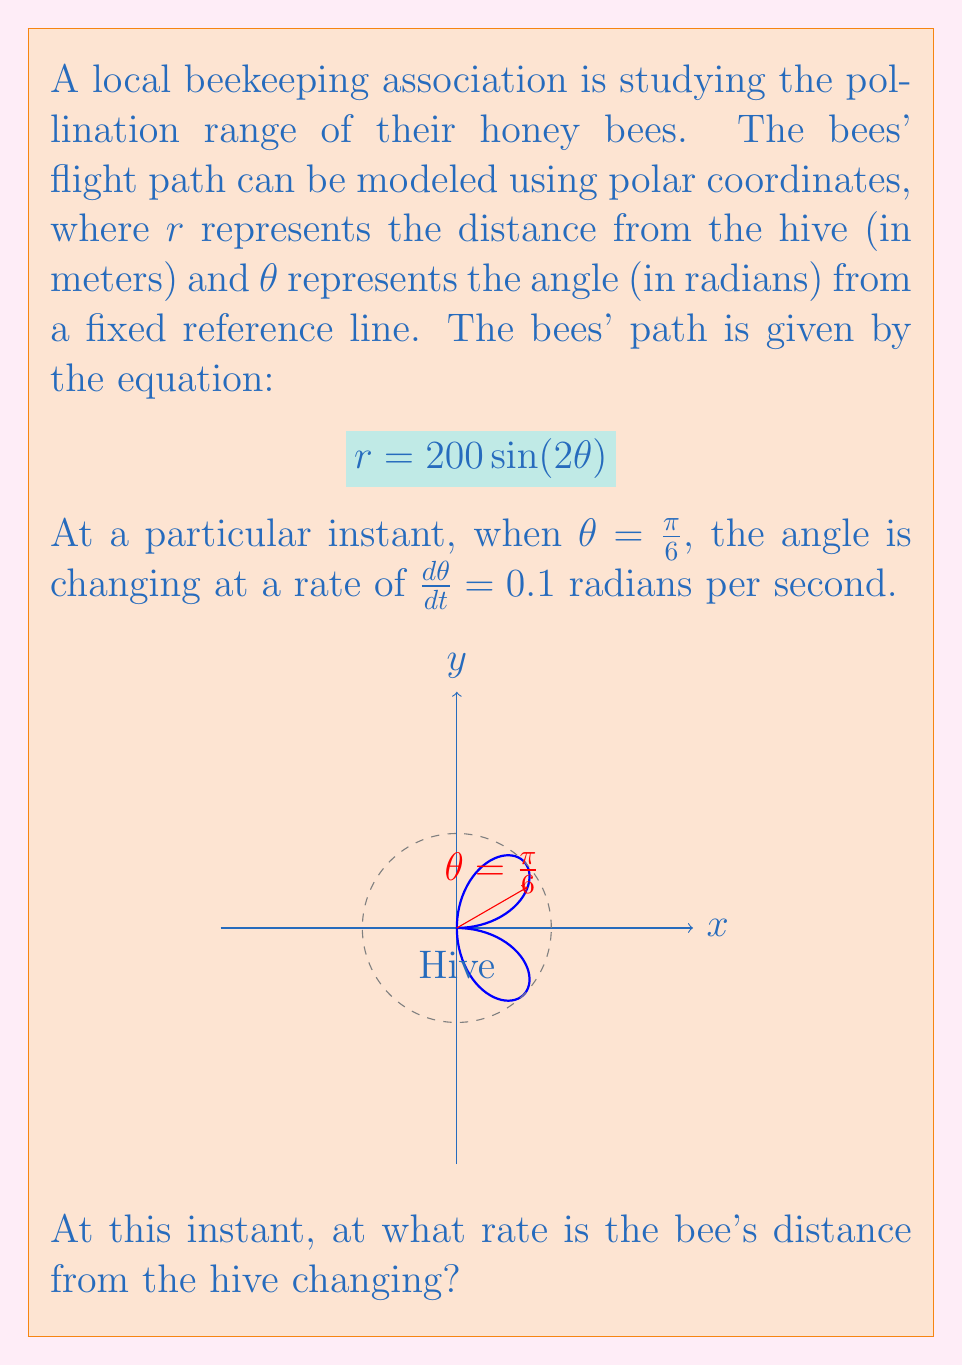What is the answer to this math problem? Let's approach this step-by-step using related rates:

1) We're given the polar equation $r = 200\sin(2\theta)$.

2) To find $\frac{dr}{dt}$, we need to use the chain rule:

   $$\frac{dr}{dt} = \frac{dr}{d\theta} \cdot \frac{d\theta}{dt}$$

3) We know $\frac{d\theta}{dt} = 0.1$ rad/s. Now we need to find $\frac{dr}{d\theta}$.

4) Differentiate $r$ with respect to $\theta$:

   $$\frac{dr}{d\theta} = 200 \cdot 2 \cos(2\theta) = 400\cos(2\theta)$$

5) At $\theta = \frac{\pi}{6}$, we need to calculate $\cos(2\theta)$:

   $$\cos(2 \cdot \frac{\pi}{6}) = \cos(\frac{\pi}{3}) = \frac{1}{2}$$

6) Now we can substitute this into our equation for $\frac{dr}{d\theta}$:

   $$\frac{dr}{d\theta} = 400 \cdot \frac{1}{2} = 200$$

7) Finally, we can calculate $\frac{dr}{dt}$:

   $$\frac{dr}{dt} = \frac{dr}{d\theta} \cdot \frac{d\theta}{dt} = 200 \cdot 0.1 = 20$$

Therefore, at this instant, the bee's distance from the hive is changing at a rate of 20 meters per second.
Answer: 20 m/s 